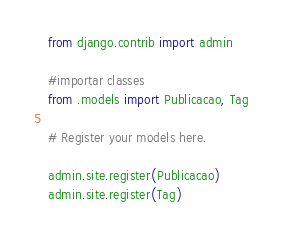Convert code to text. <code><loc_0><loc_0><loc_500><loc_500><_Python_>from django.contrib import admin

#importar classes
from .models import Publicacao, Tag

# Register your models here.

admin.site.register(Publicacao)
admin.site.register(Tag)</code> 